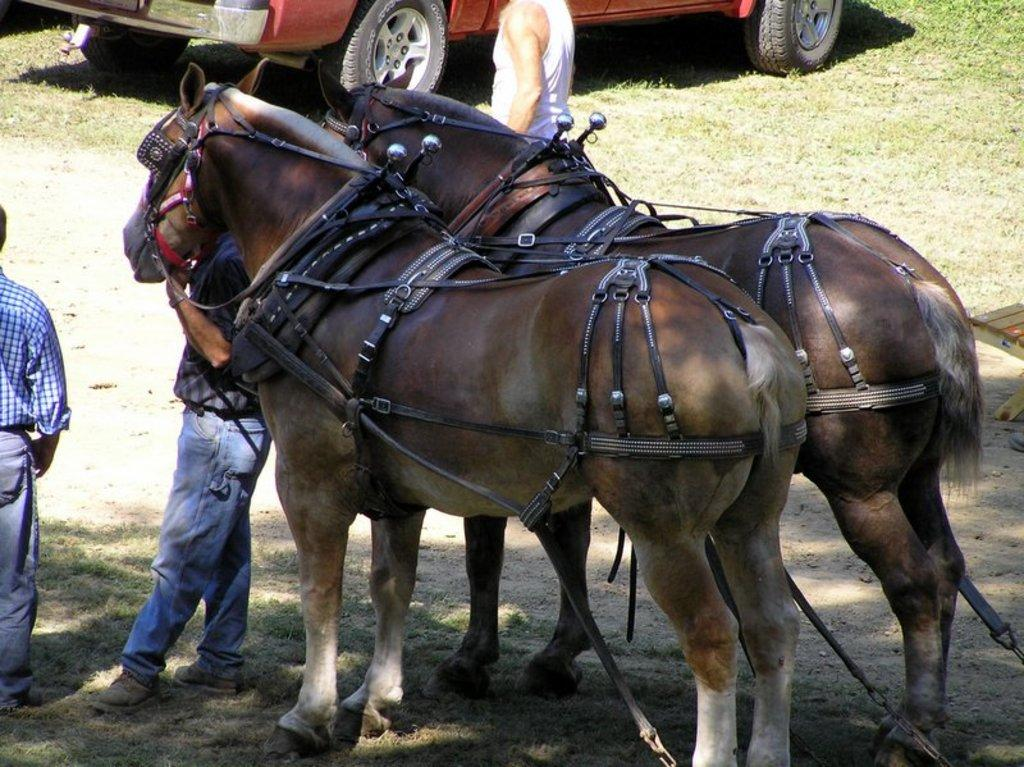What animals are on the ground in the center of the image? There are horses on the ground in the center of the image. What can be seen on the left side of the image? There are persons on the left side of the image. Can you describe the background of the image? There is a person visible in the background, along with grass and a car. What type of stamp can be seen on the horse's back in the image? There is no stamp visible on the horse's back in the image. What is the horse eating for lunch in the image? There is no indication of the horse eating lunch in the image. 